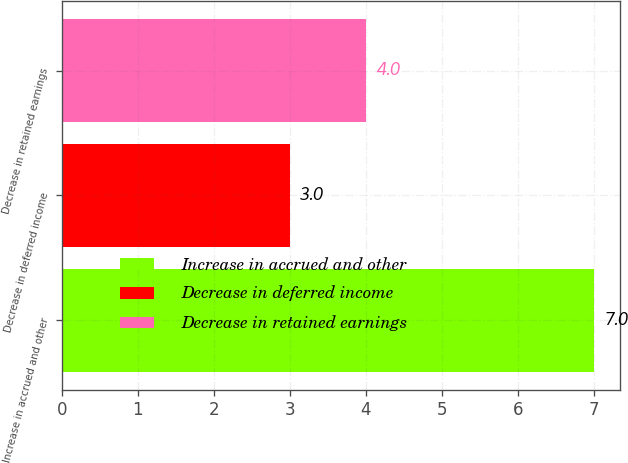Convert chart. <chart><loc_0><loc_0><loc_500><loc_500><bar_chart><fcel>Increase in accrued and other<fcel>Decrease in deferred income<fcel>Decrease in retained earnings<nl><fcel>7<fcel>3<fcel>4<nl></chart> 